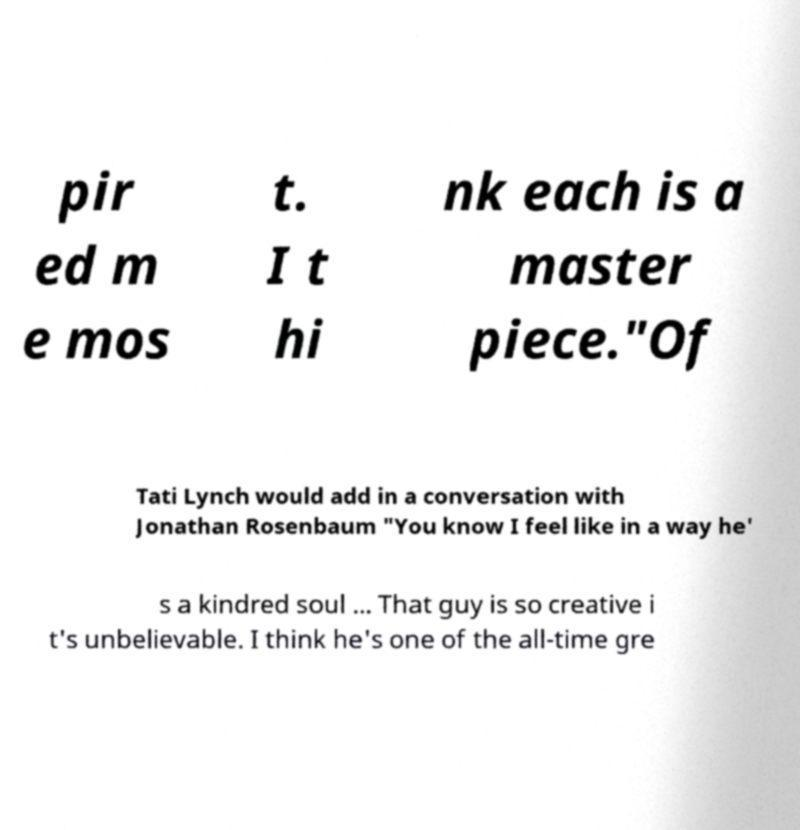For documentation purposes, I need the text within this image transcribed. Could you provide that? pir ed m e mos t. I t hi nk each is a master piece."Of Tati Lynch would add in a conversation with Jonathan Rosenbaum "You know I feel like in a way he' s a kindred soul ... That guy is so creative i t's unbelievable. I think he's one of the all-time gre 